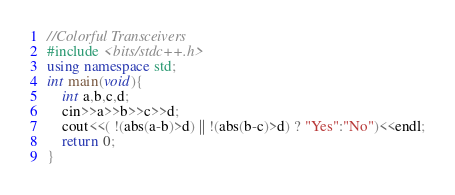Convert code to text. <code><loc_0><loc_0><loc_500><loc_500><_C++_>//Colorful Transceivers
#include <bits/stdc++.h>
using namespace std;
int main(void){
    int a,b,c,d;
    cin>>a>>b>>c>>d;
    cout<<( !(abs(a-b)>d) || !(abs(b-c)>d) ? "Yes":"No")<<endl;
    return 0;
}</code> 